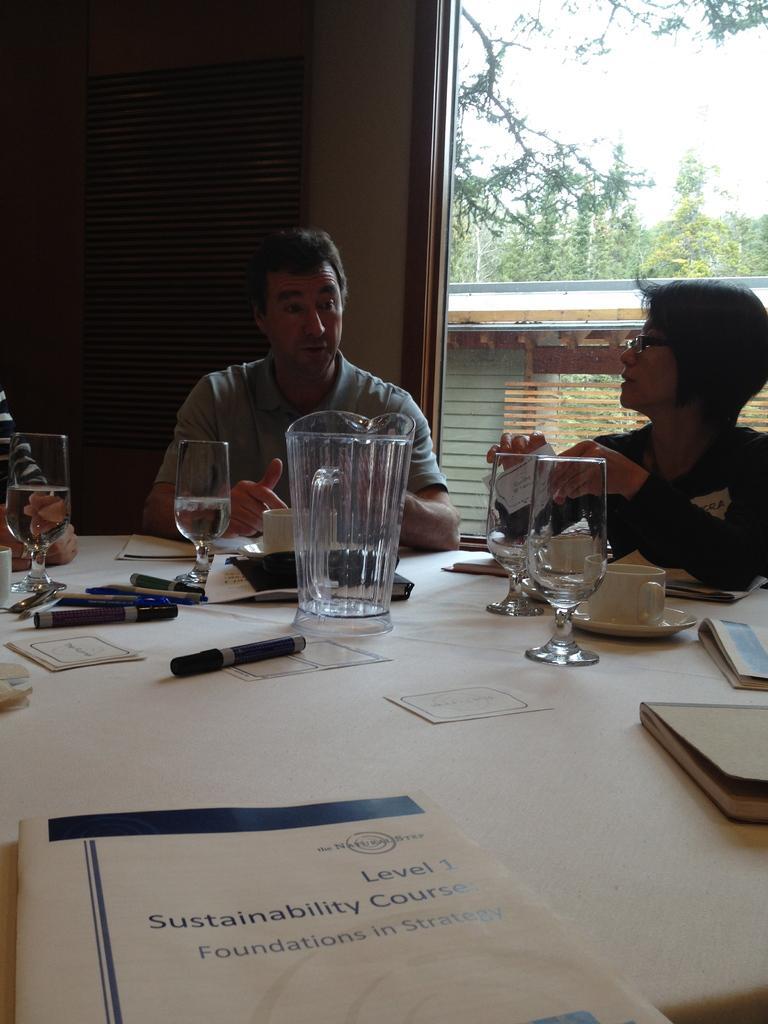Please provide a concise description of this image. In this image there is a table. On the table there is a pen and glass jar ,glasses ,cup, sauces ,books and a man sit near to the table. on the right side a woman wearing a black jacket sit near to the table. On the background there are some trees, there is a sky ,on the left side there is a wall. 